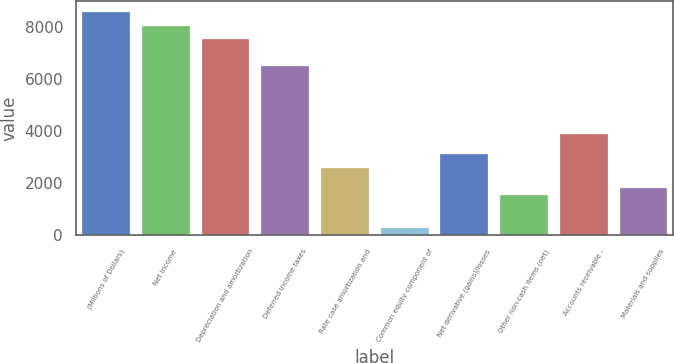Convert chart. <chart><loc_0><loc_0><loc_500><loc_500><bar_chart><fcel>(Millions of Dollars)<fcel>Net Income<fcel>Depreciation and amortization<fcel>Deferred income taxes<fcel>Rate case amortization and<fcel>Common equity component of<fcel>Net derivative (gains)/losses<fcel>Other non-cash items (net)<fcel>Accounts receivable -<fcel>Materials and supplies<nl><fcel>8569.8<fcel>8050.6<fcel>7531.4<fcel>6493<fcel>2599<fcel>262.6<fcel>3118.2<fcel>1560.6<fcel>3897<fcel>1820.2<nl></chart> 